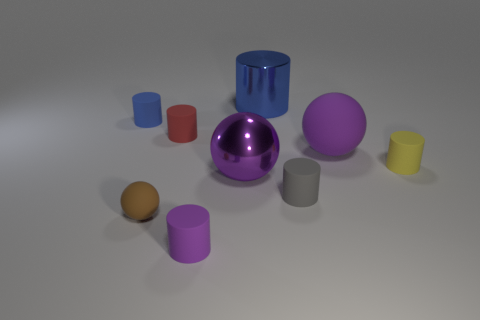Subtract all tiny red rubber cylinders. How many cylinders are left? 5 Subtract all yellow cylinders. How many cylinders are left? 5 Subtract all gray cylinders. Subtract all cyan blocks. How many cylinders are left? 5 Add 1 small brown matte objects. How many objects exist? 10 Subtract all balls. How many objects are left? 6 Subtract 0 yellow spheres. How many objects are left? 9 Subtract all large red cubes. Subtract all small brown spheres. How many objects are left? 8 Add 1 large blue cylinders. How many large blue cylinders are left? 2 Add 6 small yellow cylinders. How many small yellow cylinders exist? 7 